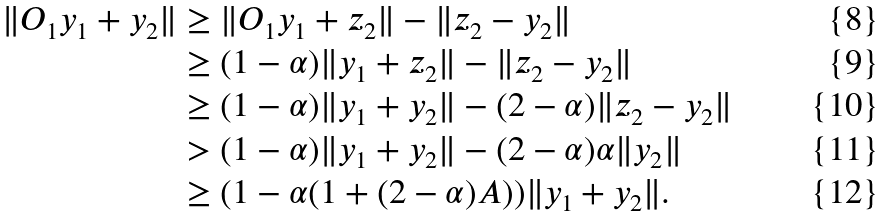<formula> <loc_0><loc_0><loc_500><loc_500>\| O _ { 1 } y _ { 1 } + y _ { 2 } \| & \geq \| O _ { 1 } y _ { 1 } + z _ { 2 } \| - \| z _ { 2 } - y _ { 2 } \| \\ & \geq ( 1 - \alpha ) \| y _ { 1 } + z _ { 2 } \| - \| z _ { 2 } - y _ { 2 } \| \\ & \geq ( 1 - \alpha ) \| y _ { 1 } + y _ { 2 } \| - ( 2 - \alpha ) \| z _ { 2 } - y _ { 2 } \| \\ & > ( 1 - \alpha ) \| y _ { 1 } + y _ { 2 } \| - ( 2 - \alpha ) \alpha \| y _ { 2 } \| \\ & \geq ( 1 - \alpha ( 1 + ( 2 - \alpha ) A ) ) \| y _ { 1 } + y _ { 2 } \| .</formula> 